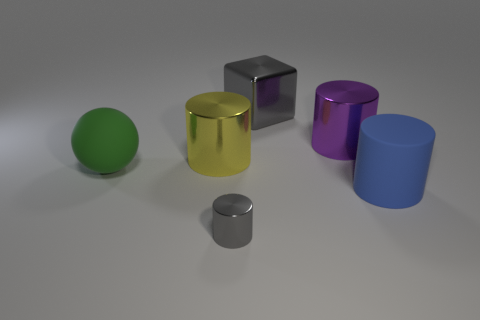Is there anything else that is the same shape as the big gray object?
Your response must be concise. No. Is there anything else that is the same size as the gray metallic cylinder?
Give a very brief answer. No. There is a large cube that is made of the same material as the small gray cylinder; what color is it?
Make the answer very short. Gray. There is a small gray thing; is its shape the same as the purple shiny object behind the small metallic object?
Provide a short and direct response. Yes. Are there any large cubes in front of the large blue object?
Your answer should be compact. No. What material is the small thing that is the same color as the shiny cube?
Give a very brief answer. Metal. Is the size of the green sphere the same as the metal cylinder that is on the right side of the large gray metal object?
Offer a terse response. Yes. Are there any rubber objects that have the same color as the small cylinder?
Keep it short and to the point. No. Are there any other cyan objects of the same shape as the small object?
Your answer should be very brief. No. What is the shape of the object that is both left of the large purple cylinder and in front of the green thing?
Make the answer very short. Cylinder. 